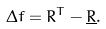Convert formula to latex. <formula><loc_0><loc_0><loc_500><loc_500>\Delta f = R ^ { T } - \underline { R } .</formula> 